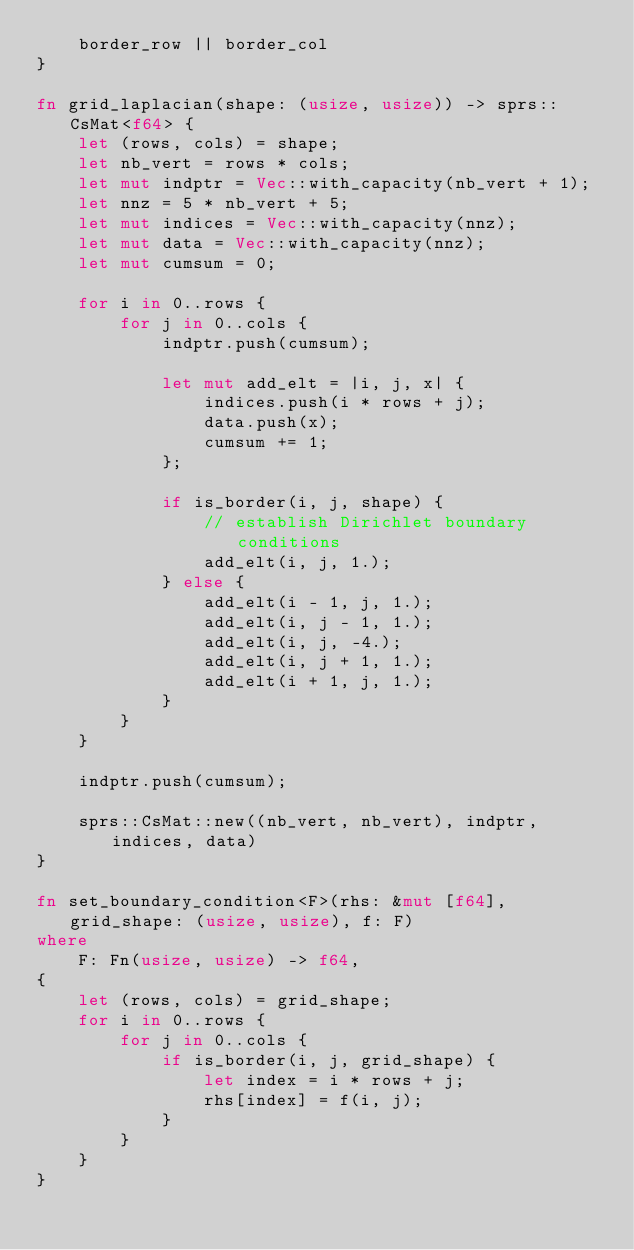<code> <loc_0><loc_0><loc_500><loc_500><_Rust_>    border_row || border_col
}

fn grid_laplacian(shape: (usize, usize)) -> sprs::CsMat<f64> {
    let (rows, cols) = shape;
    let nb_vert = rows * cols;
    let mut indptr = Vec::with_capacity(nb_vert + 1);
    let nnz = 5 * nb_vert + 5;
    let mut indices = Vec::with_capacity(nnz);
    let mut data = Vec::with_capacity(nnz);
    let mut cumsum = 0;

    for i in 0..rows {
        for j in 0..cols {
            indptr.push(cumsum);

            let mut add_elt = |i, j, x| {
                indices.push(i * rows + j);
                data.push(x);
                cumsum += 1;
            };

            if is_border(i, j, shape) {
                // establish Dirichlet boundary conditions
                add_elt(i, j, 1.);
            } else {
                add_elt(i - 1, j, 1.);
                add_elt(i, j - 1, 1.);
                add_elt(i, j, -4.);
                add_elt(i, j + 1, 1.);
                add_elt(i + 1, j, 1.);
            }
        }
    }

    indptr.push(cumsum);

    sprs::CsMat::new((nb_vert, nb_vert), indptr, indices, data)
}

fn set_boundary_condition<F>(rhs: &mut [f64], grid_shape: (usize, usize), f: F)
where
    F: Fn(usize, usize) -> f64,
{
    let (rows, cols) = grid_shape;
    for i in 0..rows {
        for j in 0..cols {
            if is_border(i, j, grid_shape) {
                let index = i * rows + j;
                rhs[index] = f(i, j);
            }
        }
    }
}
</code> 